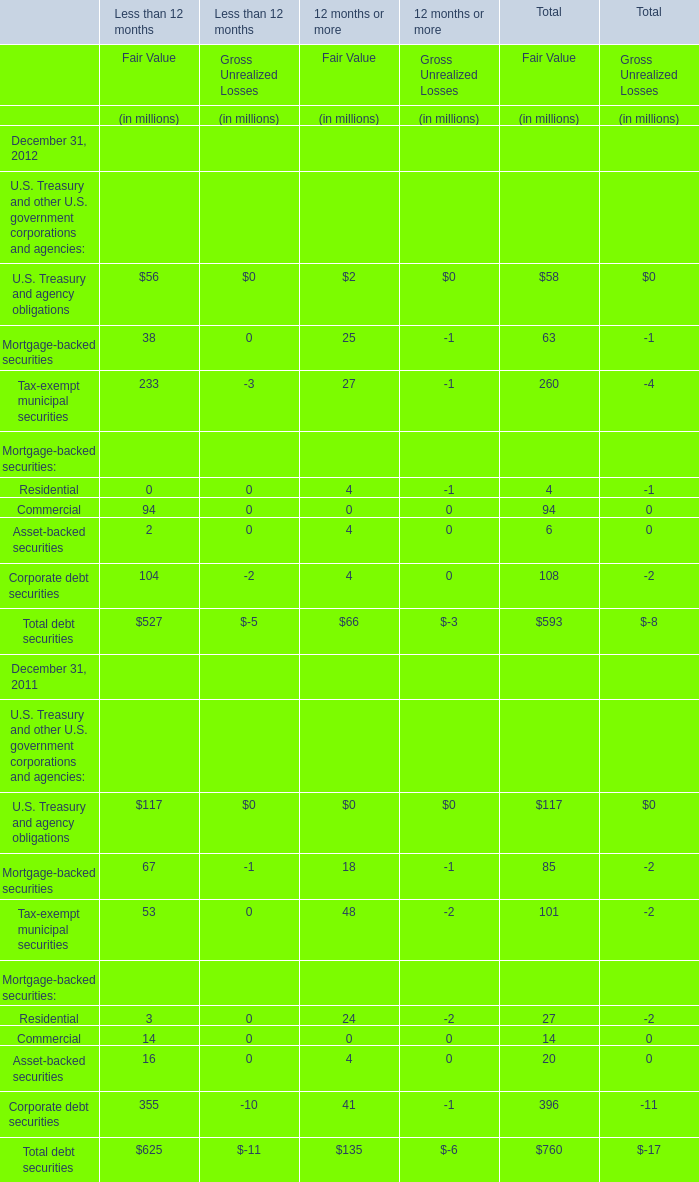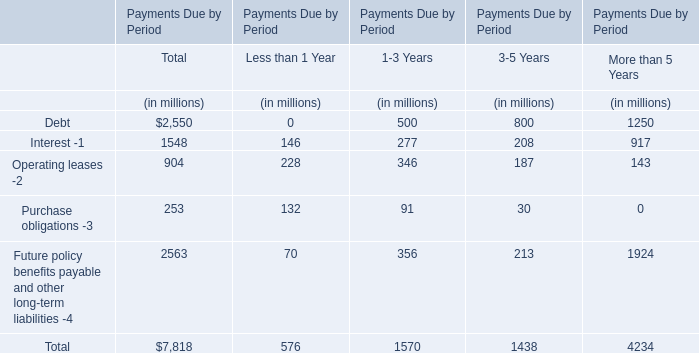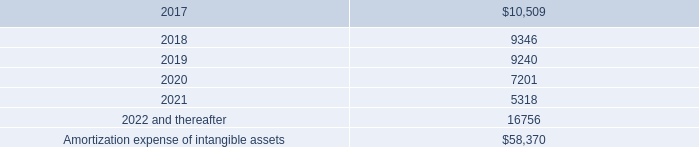At December 31,what year is Total debt securities in terms of Fair Value for 12 months or more smaller? 
Answer: 2012. 